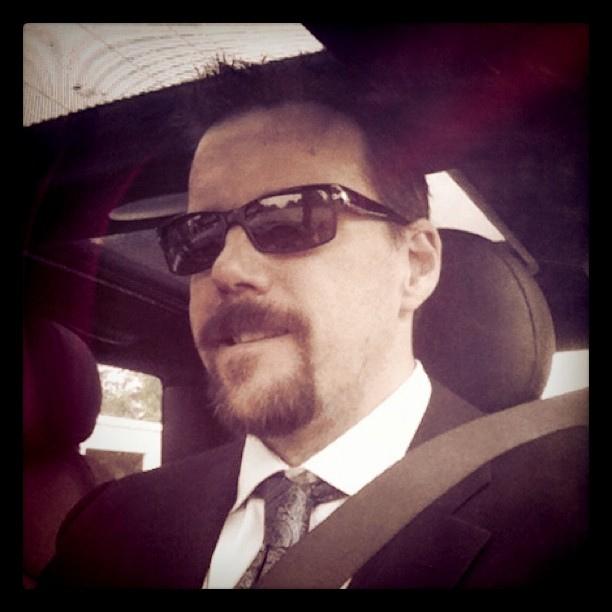Is it sunny where he is?
Be succinct. Yes. What is he sitting in?
Answer briefly. Car. What is the man wearing?
Concise answer only. Sunglasses. 